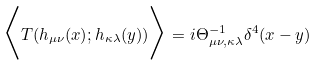Convert formula to latex. <formula><loc_0><loc_0><loc_500><loc_500>\Big { < } T ( h _ { \mu \nu } ( x ) ; h _ { \kappa \lambda } ( y ) ) \Big { > } = i \Theta ^ { - 1 } _ { \mu \nu , \kappa \lambda } \delta ^ { 4 } ( x - y )</formula> 